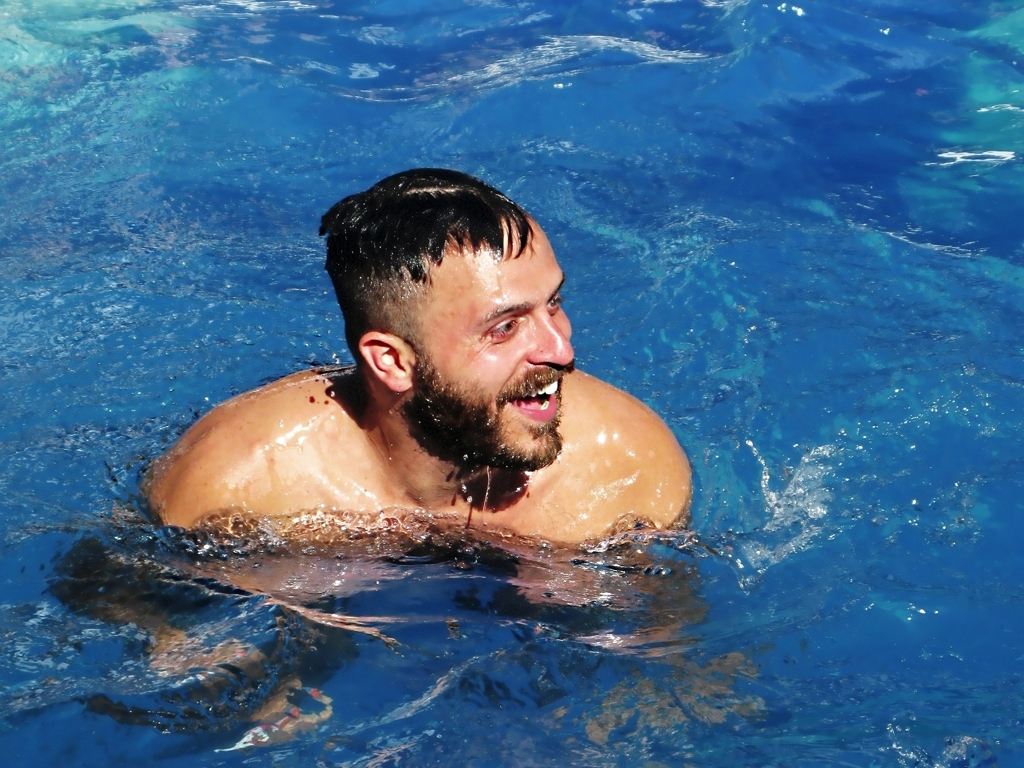How does this image relate to summer activities? This image is emblematic of common summer activities where swimming plays a central role in leisure and cooling off during hot weather. The sunny conditions, paired with the enjoyment of a refreshing dip, are typical of how many people choose to spend their warm-weather days. 